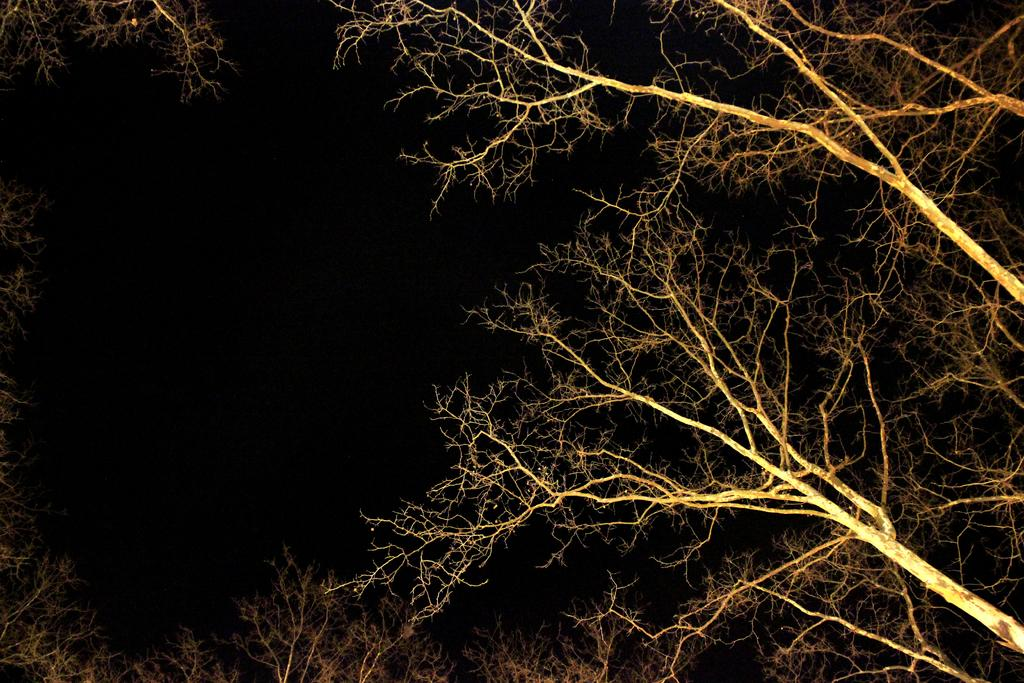What is the primary feature of the image? There are many trees in the image. What color is present in the left corner of the image? The left corner of the image is black in color. What can be inferred about the lighting conditions when the image was taken? The image was clicked in the dark. Can you describe the sense of smell in the image? There is no information about the sense of smell in the image, as it is a visual representation. 